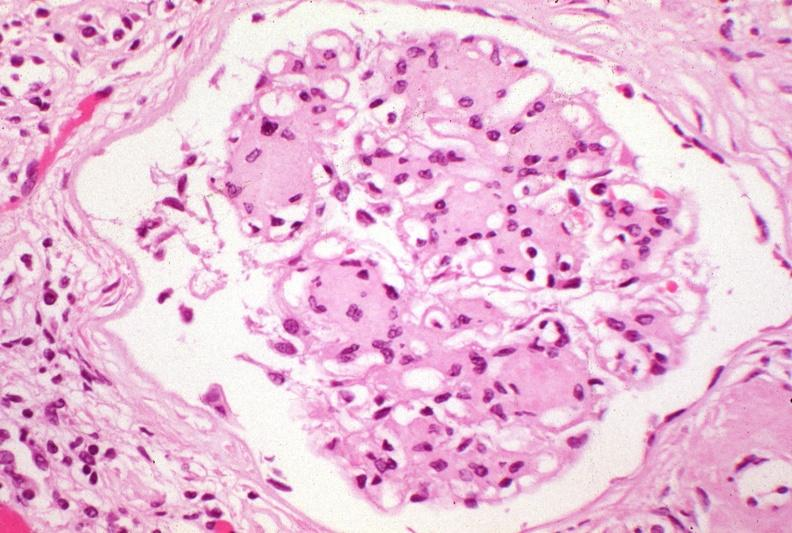what does this image show?
Answer the question using a single word or phrase. Kidney 